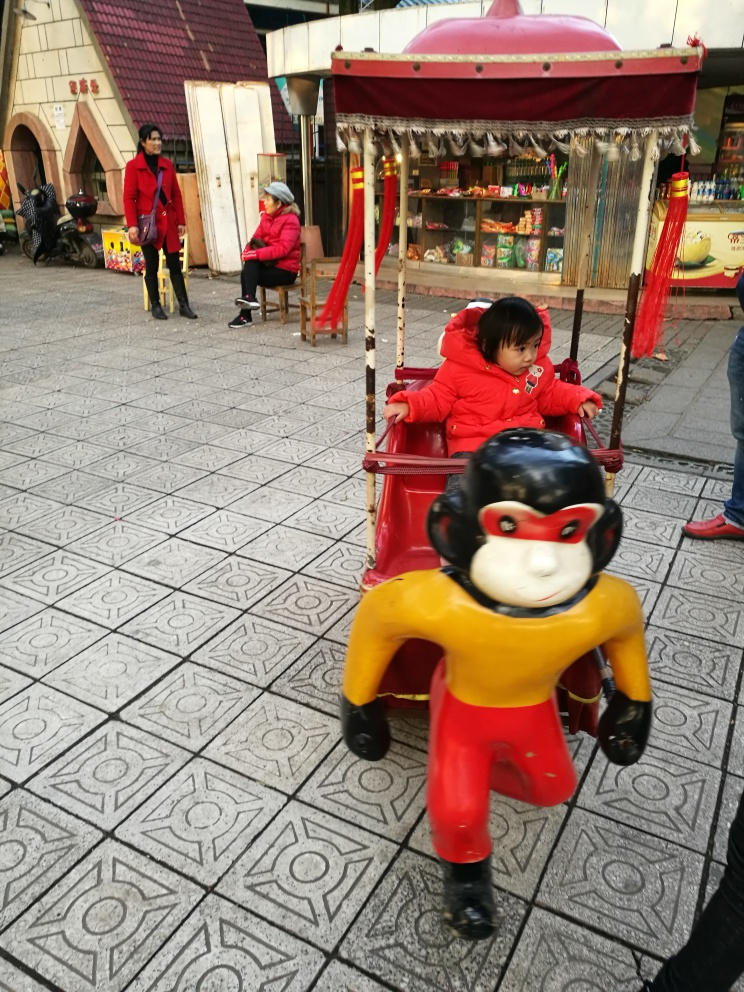What emotions does the scene in the photo evoke? The scene in the photo seems to evoke a sense of nostalgic simplicity and childhood innocence, highlighted by the child's focused play and the relaxed posture of the adults in the background. 